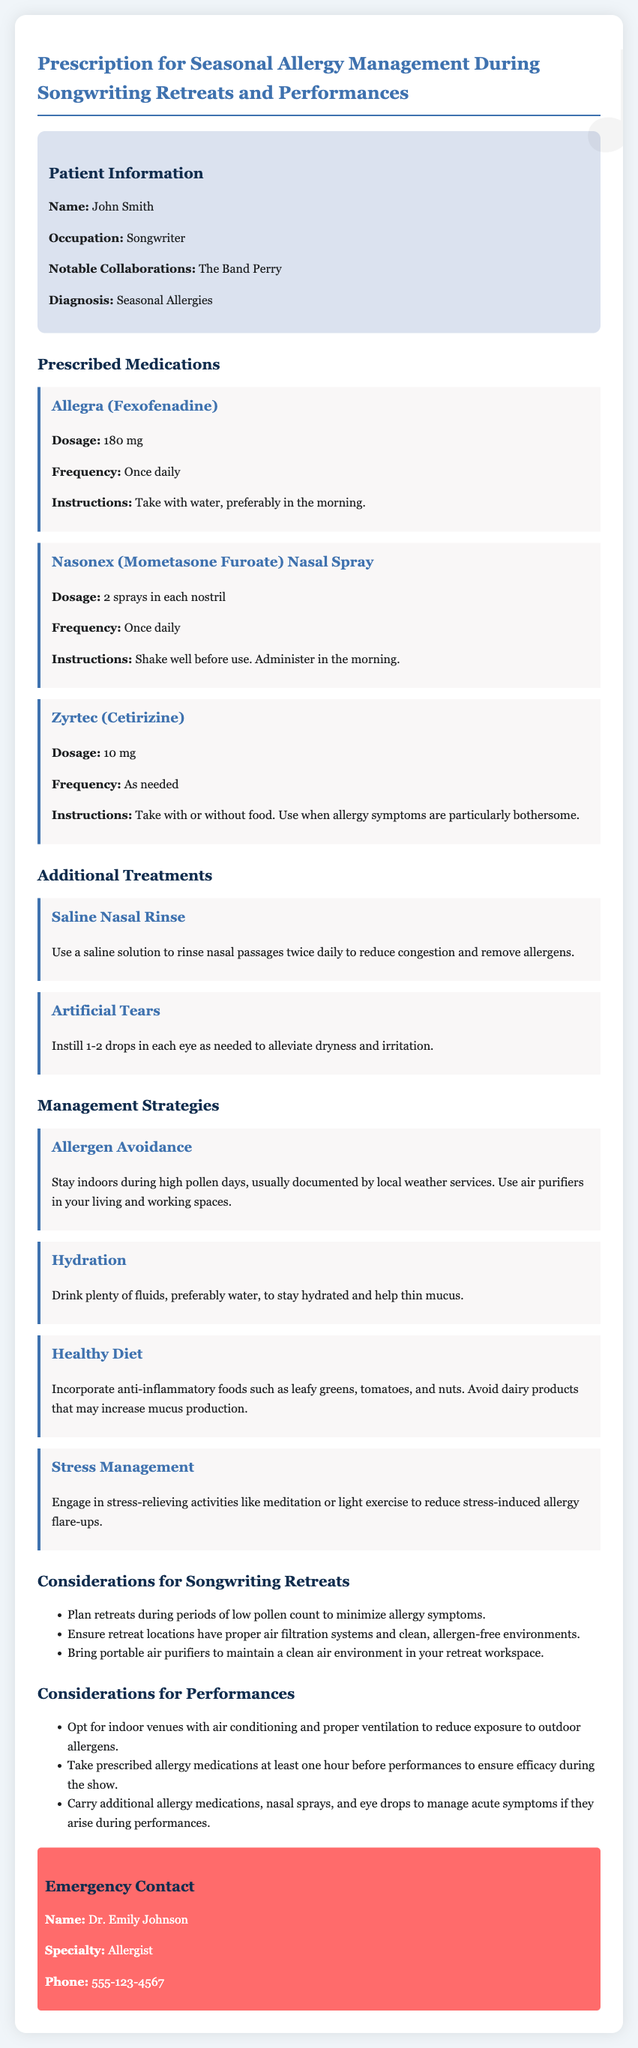What is the name of the patient? The document lists the patient's name as John Smith.
Answer: John Smith What is the prescribed dosage of Allegra? The document specifies the dosage of Allegra as 180 mg.
Answer: 180 mg How often should Nasonex be taken? The document indicates that Nasonex should be taken once daily.
Answer: Once daily What should be used to alleviate dryness in the eyes? The document suggests using artificial tears for eye dryness.
Answer: Artificial Tears What is a recommended management strategy for allergies? The document lists allergen avoidance as a management strategy.
Answer: Allergen Avoidance What is the emergency contact's specialty? The document states the emergency contact's specialty is Allergist.
Answer: Allergist What allergy medication should be taken at least an hour before performances? The document notes that prescribed allergy medications should be taken at least one hour before performances.
Answer: Prescribed allergy medications What should be included in the healthy diet? The document specifies incorporating anti-inflammatory foods.
Answer: Anti-inflammatory foods During what period should retreats be planned? The document suggests planning retreats during periods of low pollen count.
Answer: Low pollen count 